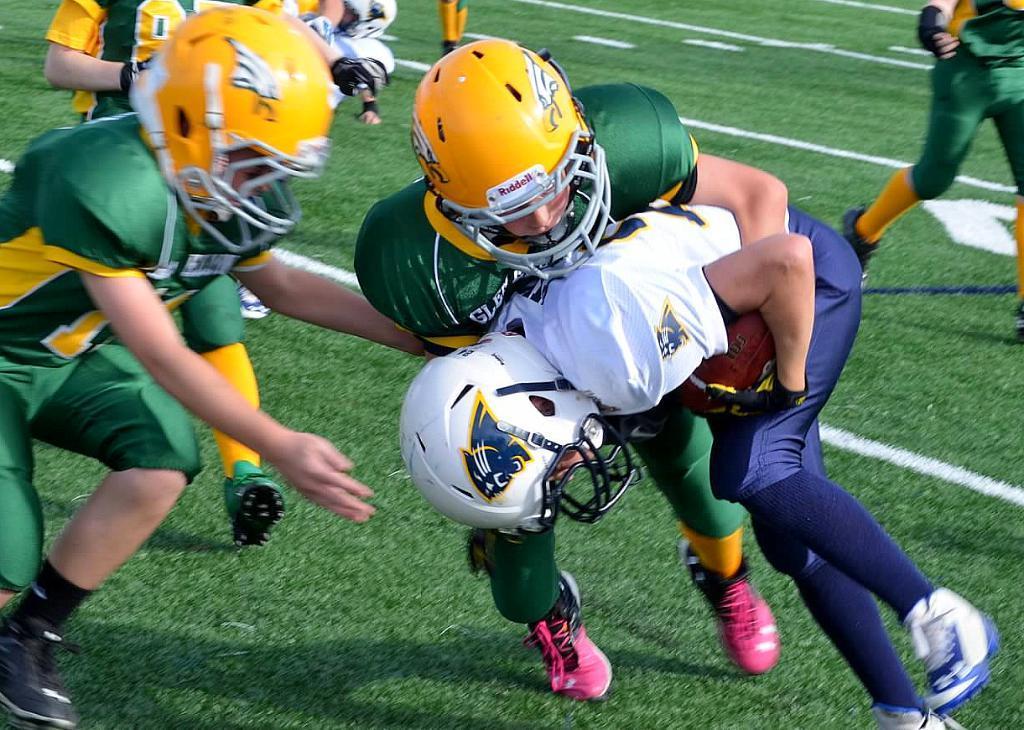Can you describe this image briefly? In this picture there is a man who is wearing helmet, white t-shirt, blue trouser and shoes. He is holding ball. Beside him I can see the opponent players who are wearing yellow helmets, green t-shirts, shorts and shoes. Behind them I can see the referee who is wearing yellow t-shirt, short and shoes. In the back I can see some persons who are running on the ground. 